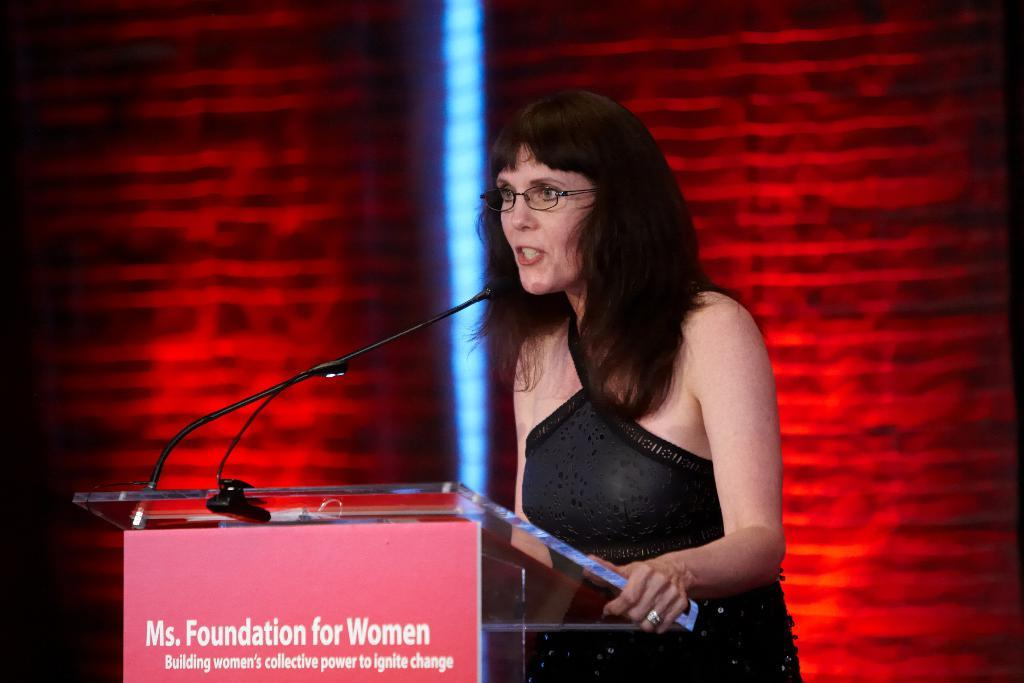Who is the main subject in the image? There is a woman in the image. What is the woman doing in the image? The woman is standing and speaking into a microphone. What can be seen on the woman's face? The woman is wearing glasses (specs) in the image. What is the color of the microphone? The microphone is black in color. What is the color of the wall in the background of the image? There is a red color wall in the background of the image. What type of magic is the woman performing with the engine in the image? There is no magic or engine present in the image. What kind of agreement is the woman discussing with the other party in the image? There is no indication of an agreement or another party in the image; the woman is speaking into a microphone. 